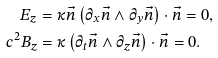Convert formula to latex. <formula><loc_0><loc_0><loc_500><loc_500>E _ { z } & = \kappa \vec { n } \left ( \partial _ { x } \vec { n } \wedge \partial _ { y } \vec { n } \right ) \cdot \vec { n } = 0 , \\ c ^ { 2 } B _ { z } & = \kappa \left ( \partial _ { t } \vec { n } \wedge \partial _ { z } \vec { n } \right ) \cdot \vec { n } = 0 .</formula> 